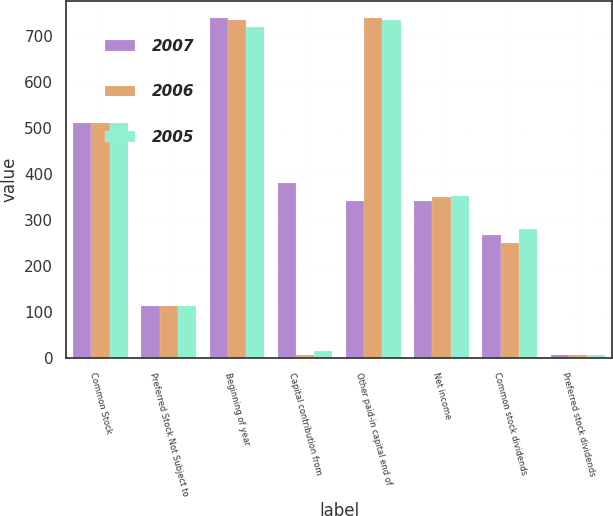<chart> <loc_0><loc_0><loc_500><loc_500><stacked_bar_chart><ecel><fcel>Common Stock<fcel>Preferred Stock Not Subject to<fcel>Beginning of year<fcel>Capital contribution from<fcel>Other paid-in capital end of<fcel>Net income<fcel>Common stock dividends<fcel>Preferred stock dividends<nl><fcel>2007<fcel>511<fcel>113<fcel>739<fcel>380<fcel>342<fcel>342<fcel>267<fcel>6<nl><fcel>2006<fcel>511<fcel>113<fcel>733<fcel>6<fcel>739<fcel>349<fcel>249<fcel>6<nl><fcel>2005<fcel>511<fcel>113<fcel>718<fcel>15<fcel>733<fcel>352<fcel>280<fcel>6<nl></chart> 